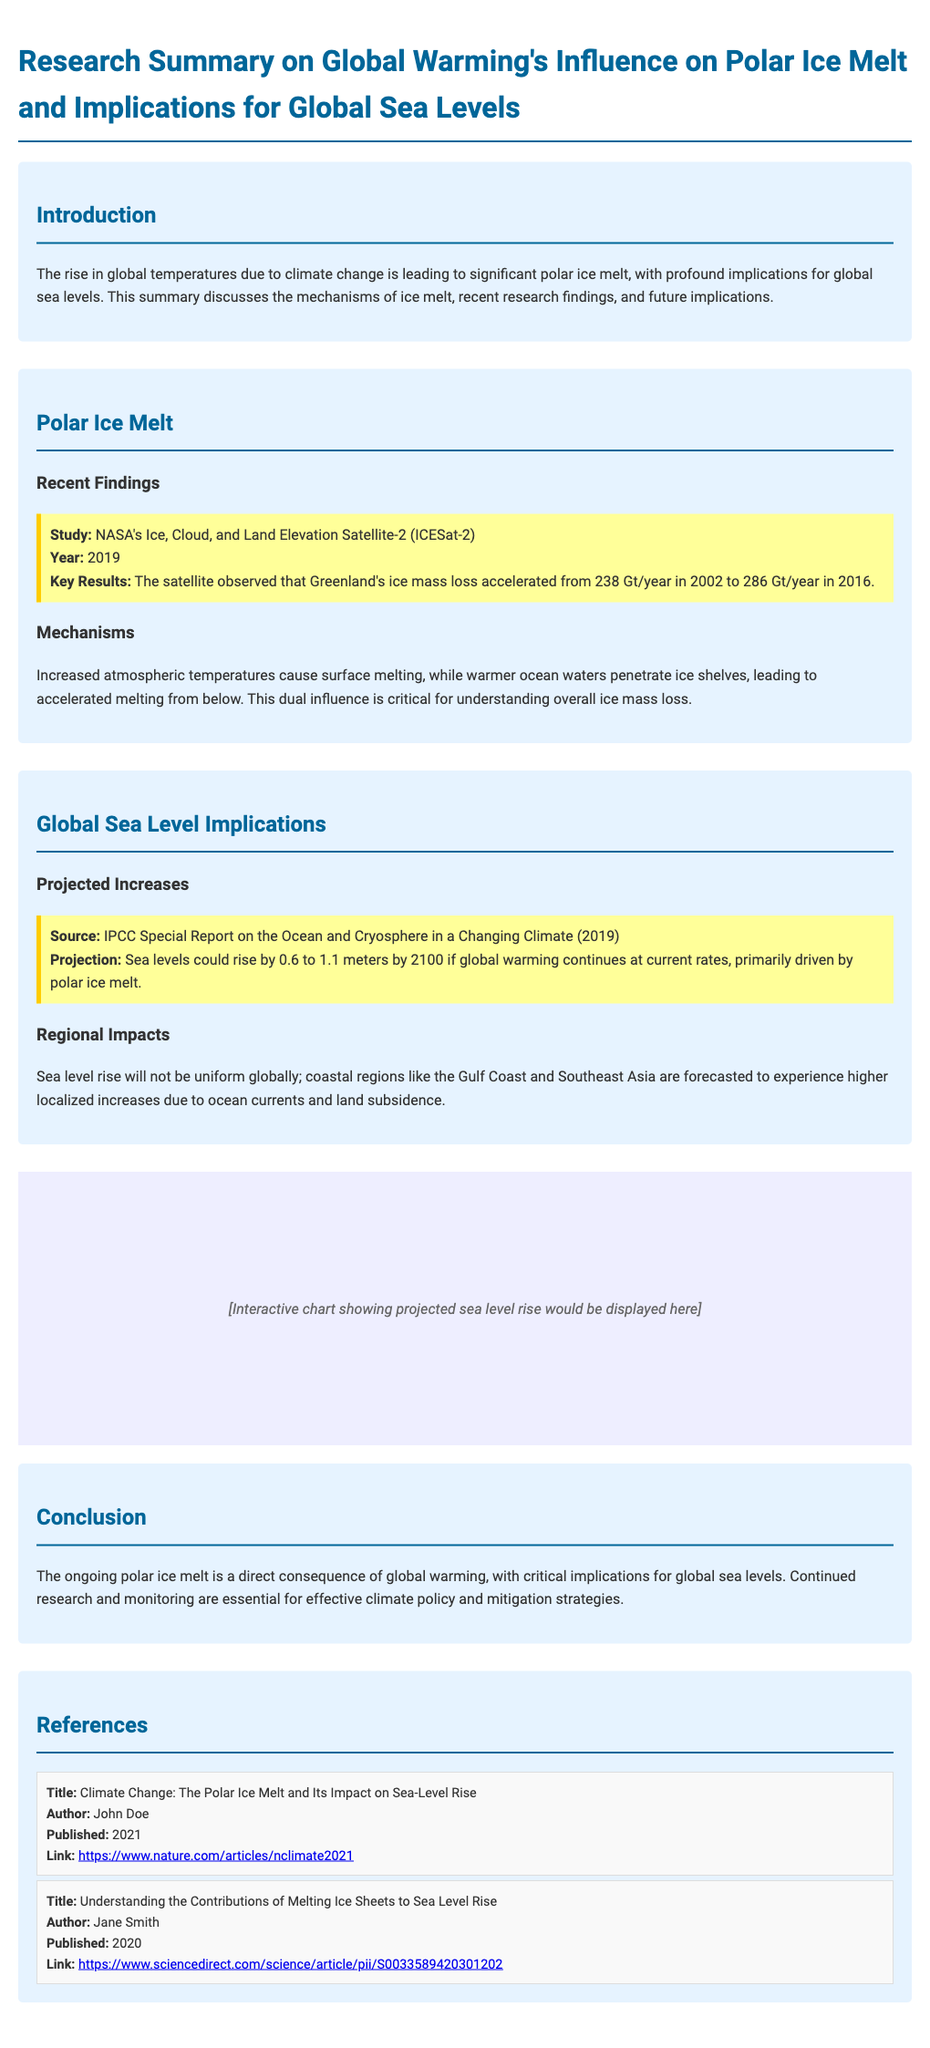what is the title of the document? The title of the document is provided in the header section.
Answer: Research Summary on Global Warming's Influence on Polar Ice Melt and Implications for Global Sea Levels what year did ICESat-2 report its findings? The year of the findings is mentioned in the "Recent Findings" section.
Answer: 2019 how much ice mass loss did Greenland experience per year in 2016? This figure is stated in the highlight of the "Recent Findings" section.
Answer: 286 Gt/year what could be the projected rise in sea levels by 2100? The projection is found in the "Projected Increases" section, specifically related to global warming rates.
Answer: 0.6 to 1.1 meters which regions are forecasted to experience higher localized sea level increases? This is mentioned in the "Regional Impacts" section discussing the effects of sea level rise.
Answer: Gulf Coast and Southeast Asia who is the author of the reference titled "Climate Change: The Polar Ice Melt and Its Impact on Sea-Level Rise"? The authors of the references are specified in the "References" section.
Answer: John Doe what is one of the mechanisms causing polar ice melt? The mechanisms of ice melt are described in the "Mechanisms" subsection.
Answer: Surface melting what is the publication year of Jane Smith's reference? The publication year is provided in the reference entry for Jane Smith's article.
Answer: 2020 